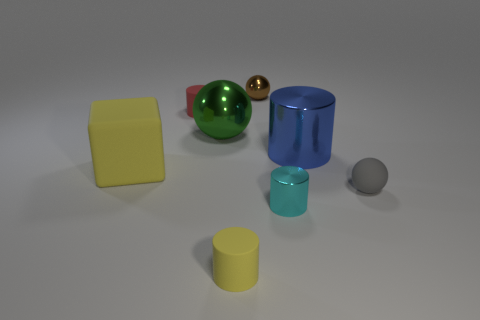What number of cylinders are small brown shiny things or green things?
Ensure brevity in your answer.  0. How many large purple blocks are the same material as the tiny gray sphere?
Your answer should be very brief. 0. The object that is the same color as the block is what shape?
Your answer should be very brief. Cylinder. The tiny object that is both behind the cyan thing and to the left of the small brown object is made of what material?
Offer a terse response. Rubber. What is the shape of the yellow thing right of the yellow cube?
Your answer should be very brief. Cylinder. There is a small object behind the matte cylinder that is behind the big blue metal thing; what shape is it?
Your response must be concise. Sphere. Are there any other green objects of the same shape as the large green object?
Provide a short and direct response. No. There is a cyan metallic object that is the same size as the brown thing; what shape is it?
Your answer should be compact. Cylinder. There is a big object that is to the right of the tiny matte cylinder in front of the small gray thing; are there any yellow matte cylinders behind it?
Make the answer very short. No. Is there a blue metal thing that has the same size as the cyan metallic object?
Provide a short and direct response. No. 